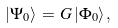Convert formula to latex. <formula><loc_0><loc_0><loc_500><loc_500>| \Psi _ { 0 } \rangle \, = \, G \, | \Phi _ { 0 } \rangle \, ,</formula> 